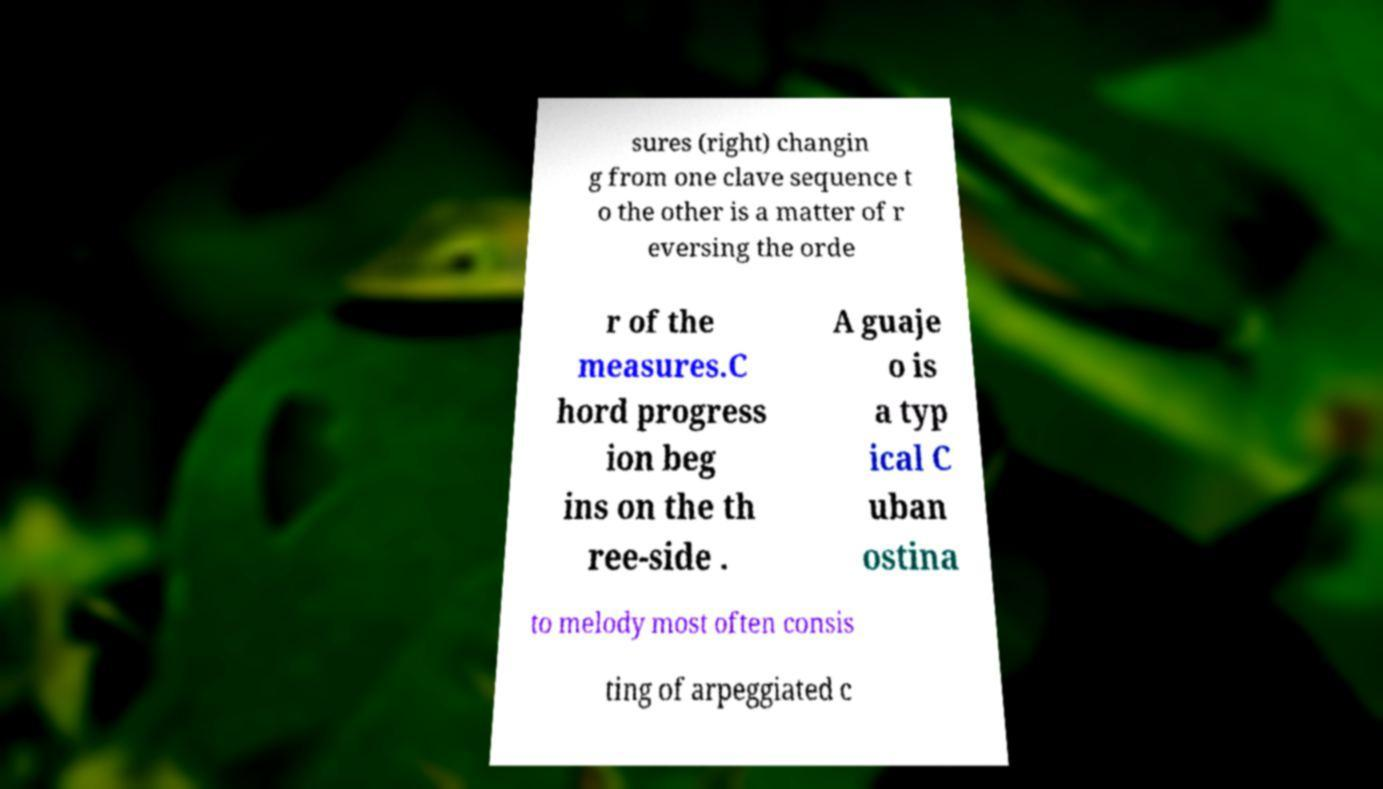Can you accurately transcribe the text from the provided image for me? sures (right) changin g from one clave sequence t o the other is a matter of r eversing the orde r of the measures.C hord progress ion beg ins on the th ree-side . A guaje o is a typ ical C uban ostina to melody most often consis ting of arpeggiated c 